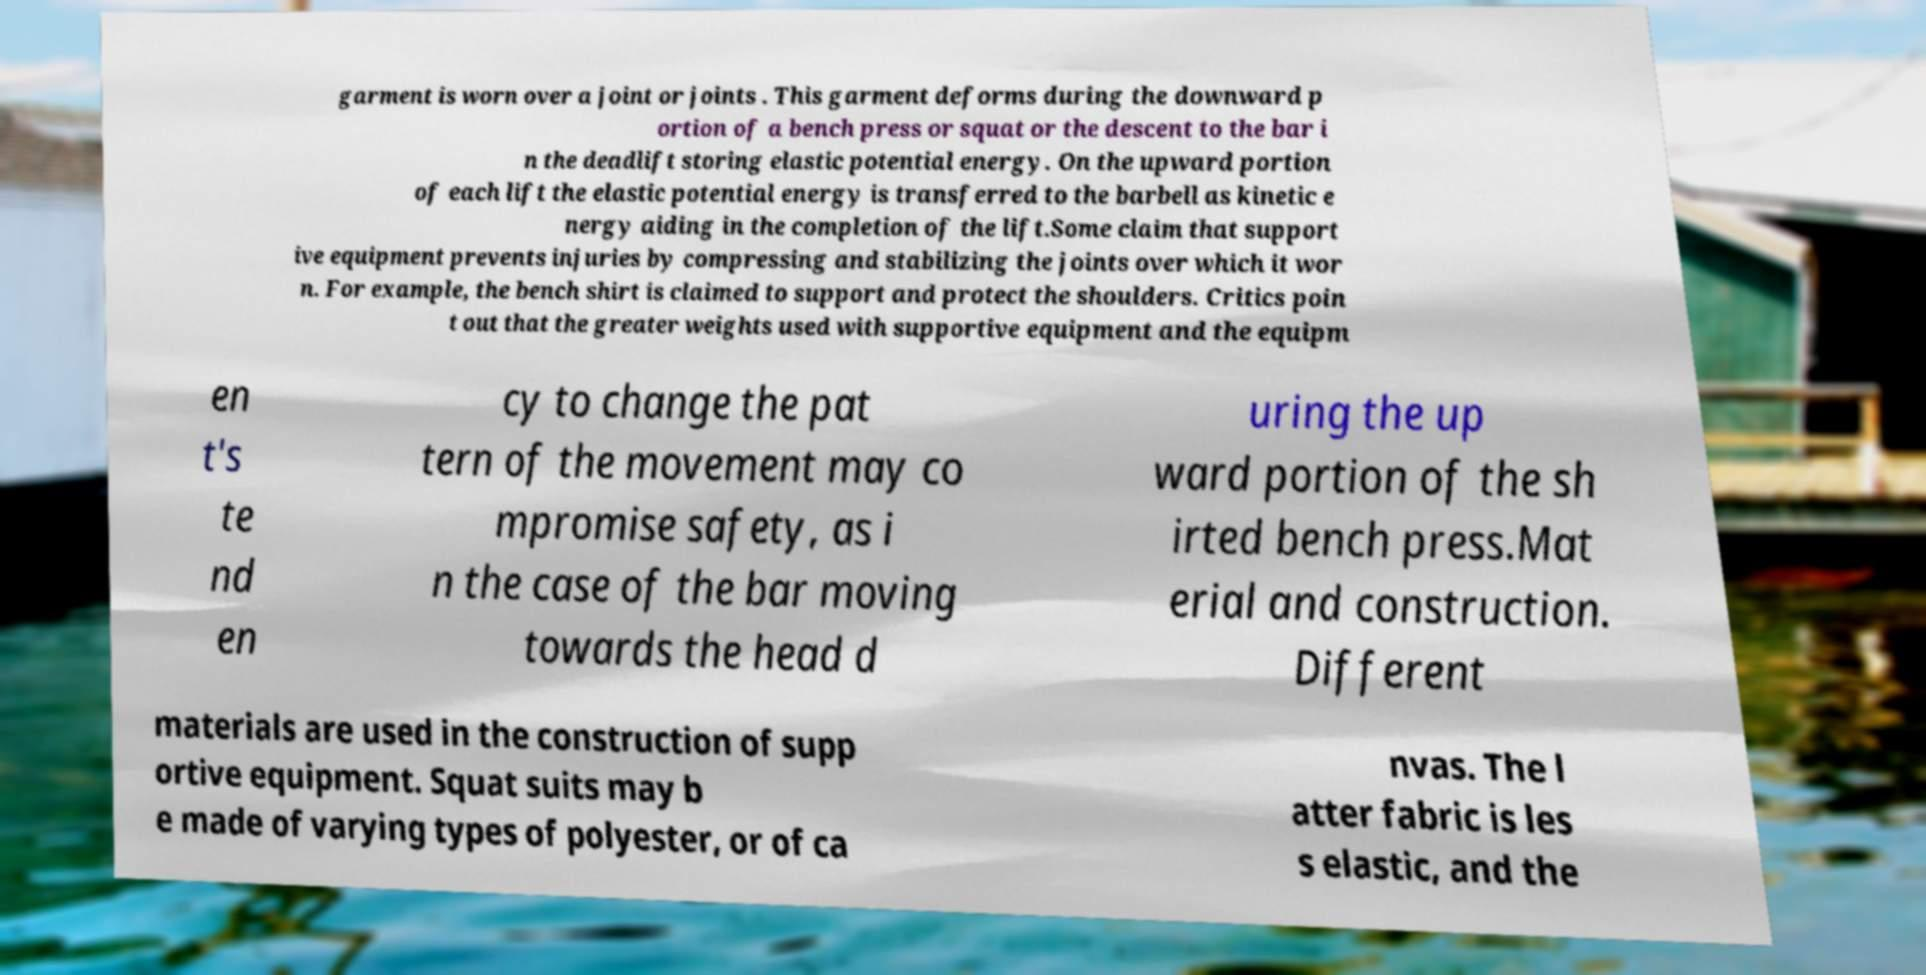Please identify and transcribe the text found in this image. garment is worn over a joint or joints . This garment deforms during the downward p ortion of a bench press or squat or the descent to the bar i n the deadlift storing elastic potential energy. On the upward portion of each lift the elastic potential energy is transferred to the barbell as kinetic e nergy aiding in the completion of the lift.Some claim that support ive equipment prevents injuries by compressing and stabilizing the joints over which it wor n. For example, the bench shirt is claimed to support and protect the shoulders. Critics poin t out that the greater weights used with supportive equipment and the equipm en t's te nd en cy to change the pat tern of the movement may co mpromise safety, as i n the case of the bar moving towards the head d uring the up ward portion of the sh irted bench press.Mat erial and construction. Different materials are used in the construction of supp ortive equipment. Squat suits may b e made of varying types of polyester, or of ca nvas. The l atter fabric is les s elastic, and the 